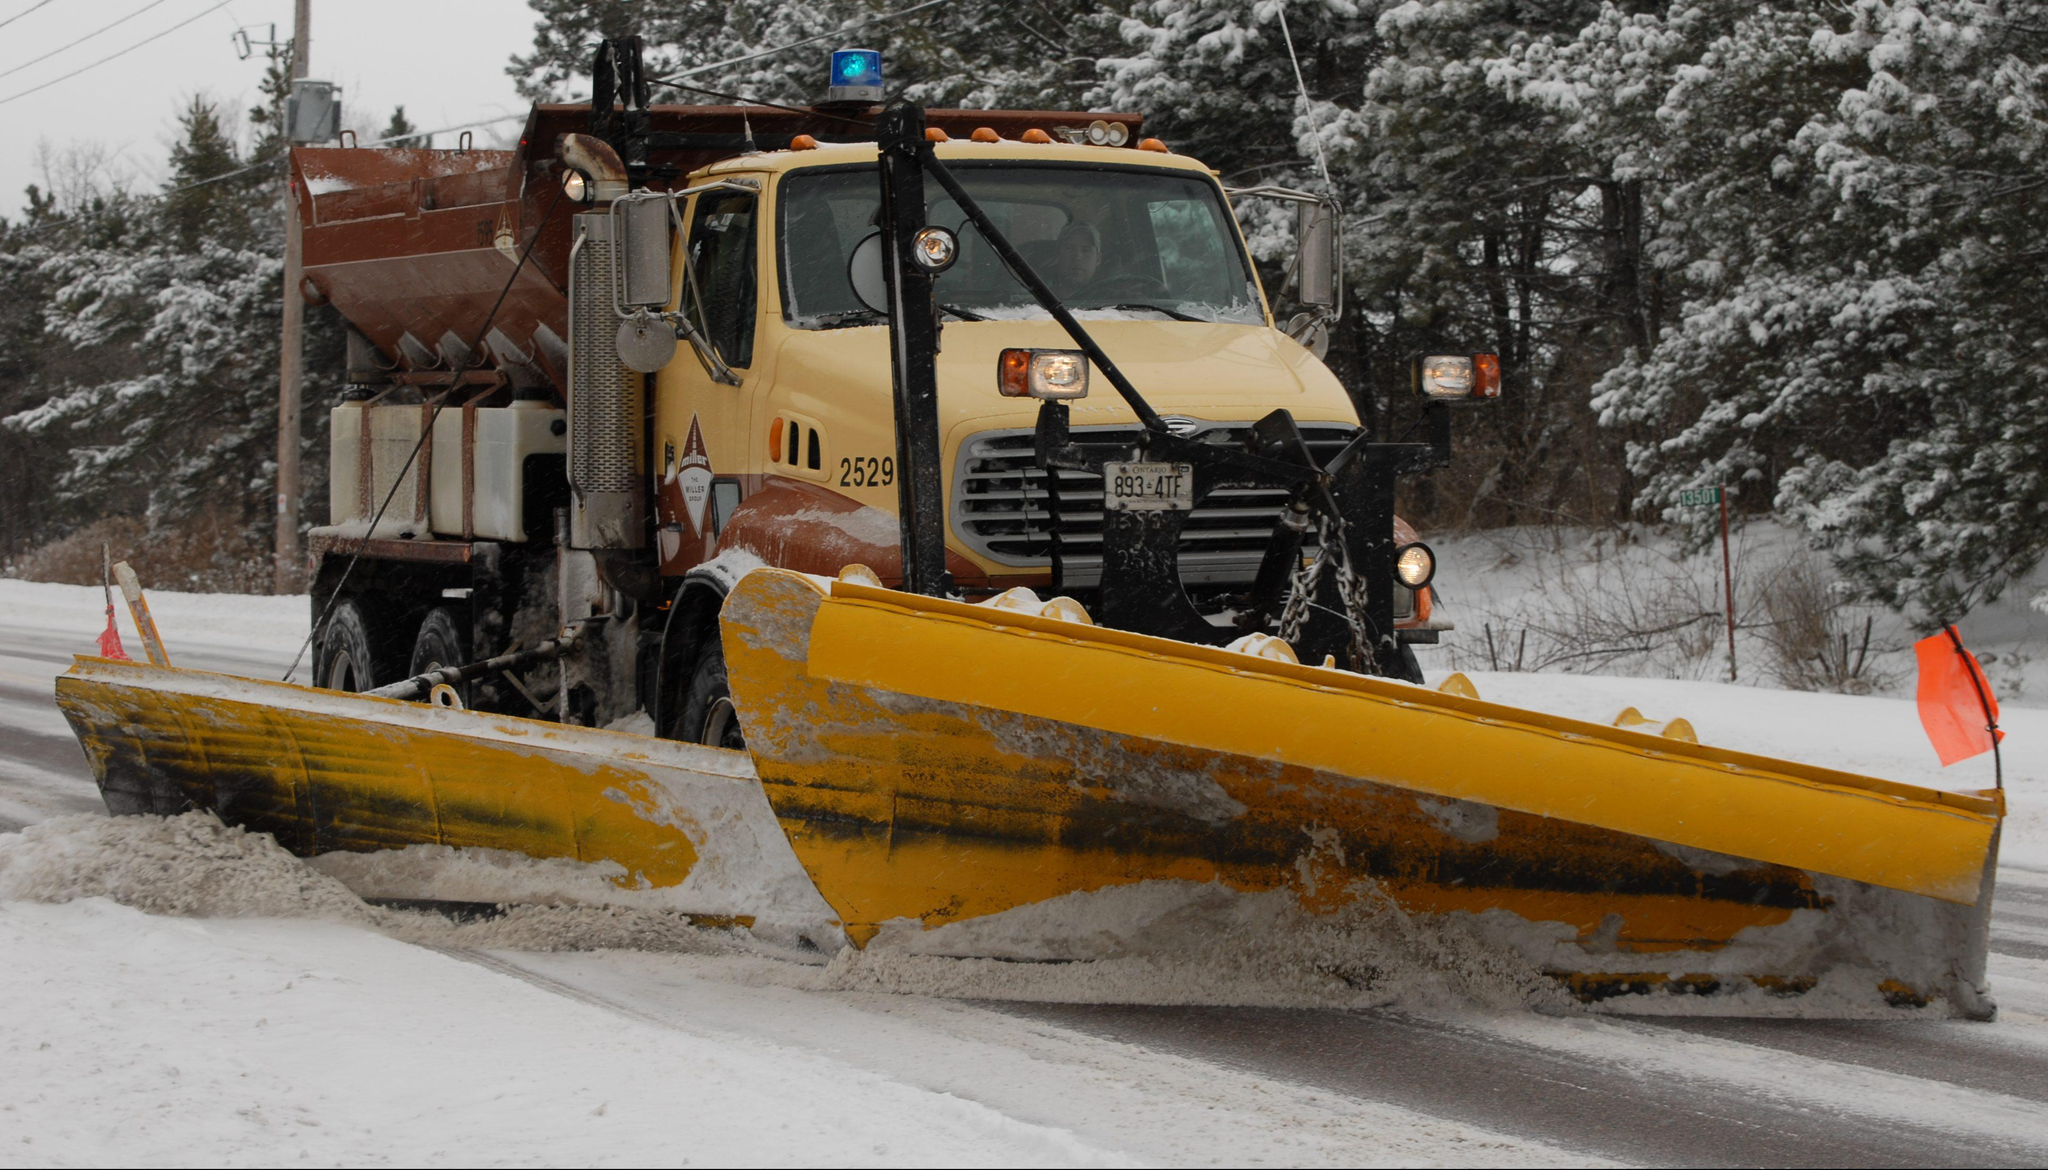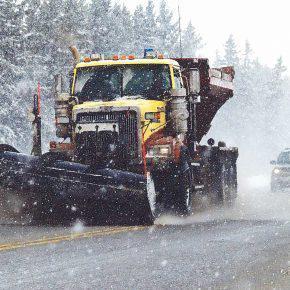The first image is the image on the left, the second image is the image on the right. For the images displayed, is the sentence "None of these trucks are pushing snow." factually correct? Answer yes or no. No. The first image is the image on the left, the second image is the image on the right. Given the left and right images, does the statement "At least one snow plow is driving down the road clearing snow." hold true? Answer yes or no. Yes. 